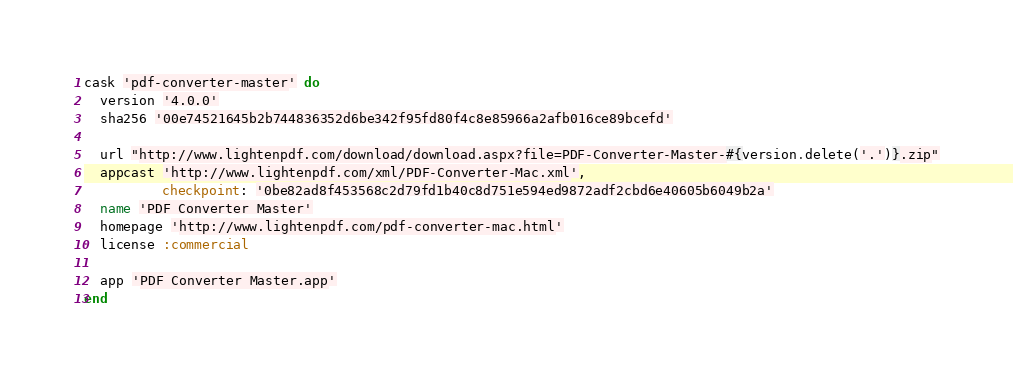Convert code to text. <code><loc_0><loc_0><loc_500><loc_500><_Ruby_>cask 'pdf-converter-master' do
  version '4.0.0'
  sha256 '00e74521645b2b744836352d6be342f95fd80f4c8e85966a2afb016ce89bcefd'

  url "http://www.lightenpdf.com/download/download.aspx?file=PDF-Converter-Master-#{version.delete('.')}.zip"
  appcast 'http://www.lightenpdf.com/xml/PDF-Converter-Mac.xml',
          checkpoint: '0be82ad8f453568c2d79fd1b40c8d751e594ed9872adf2cbd6e40605b6049b2a'
  name 'PDF Converter Master'
  homepage 'http://www.lightenpdf.com/pdf-converter-mac.html'
  license :commercial

  app 'PDF Converter Master.app'
end
</code> 